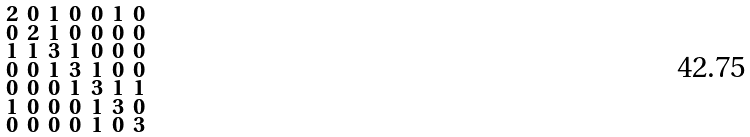<formula> <loc_0><loc_0><loc_500><loc_500>\begin{smallmatrix} 2 & 0 & 1 & 0 & 0 & 1 & 0 \\ 0 & 2 & 1 & 0 & 0 & 0 & 0 \\ 1 & 1 & 3 & 1 & 0 & 0 & 0 \\ 0 & 0 & 1 & 3 & 1 & 0 & 0 \\ 0 & 0 & 0 & 1 & 3 & 1 & 1 \\ 1 & 0 & 0 & 0 & 1 & 3 & 0 \\ 0 & 0 & 0 & 0 & 1 & 0 & 3 \end{smallmatrix}</formula> 